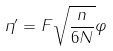<formula> <loc_0><loc_0><loc_500><loc_500>\eta ^ { \prime } = F \sqrt { \frac { n } { 6 N } } \varphi</formula> 